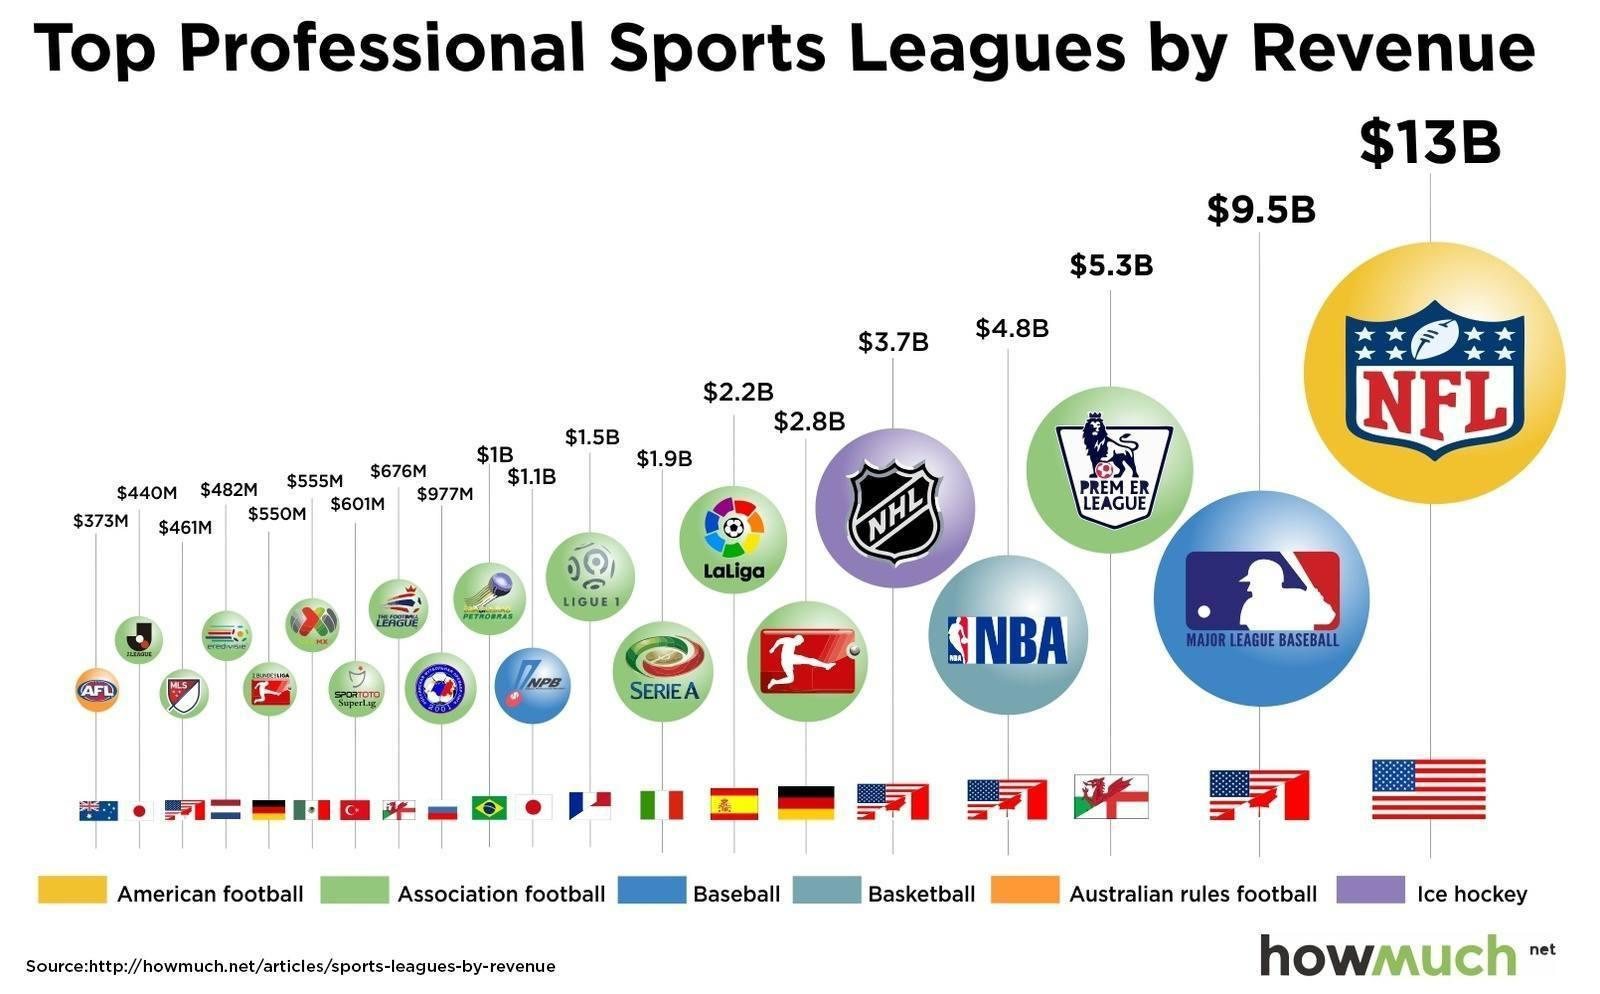Which American professional baseball league has generated the highest revenue?
Answer the question with a short phrase. MAJOR LEAGUE BASEBALL What is the revenue generated by Premier League? $5.3B Which is the professional ice hockey league in North America? NHL Which professional sports league has generated the highest revenue? NFL Which country's football league is the NFL - Canada, US, Spain, Germany? US Which country's football league is LaLiga - Canada, US, Spain, Germany? Spain Which professional football league has generated the least revenue? AFL What is the revenue generated by NBA? $4.8B 